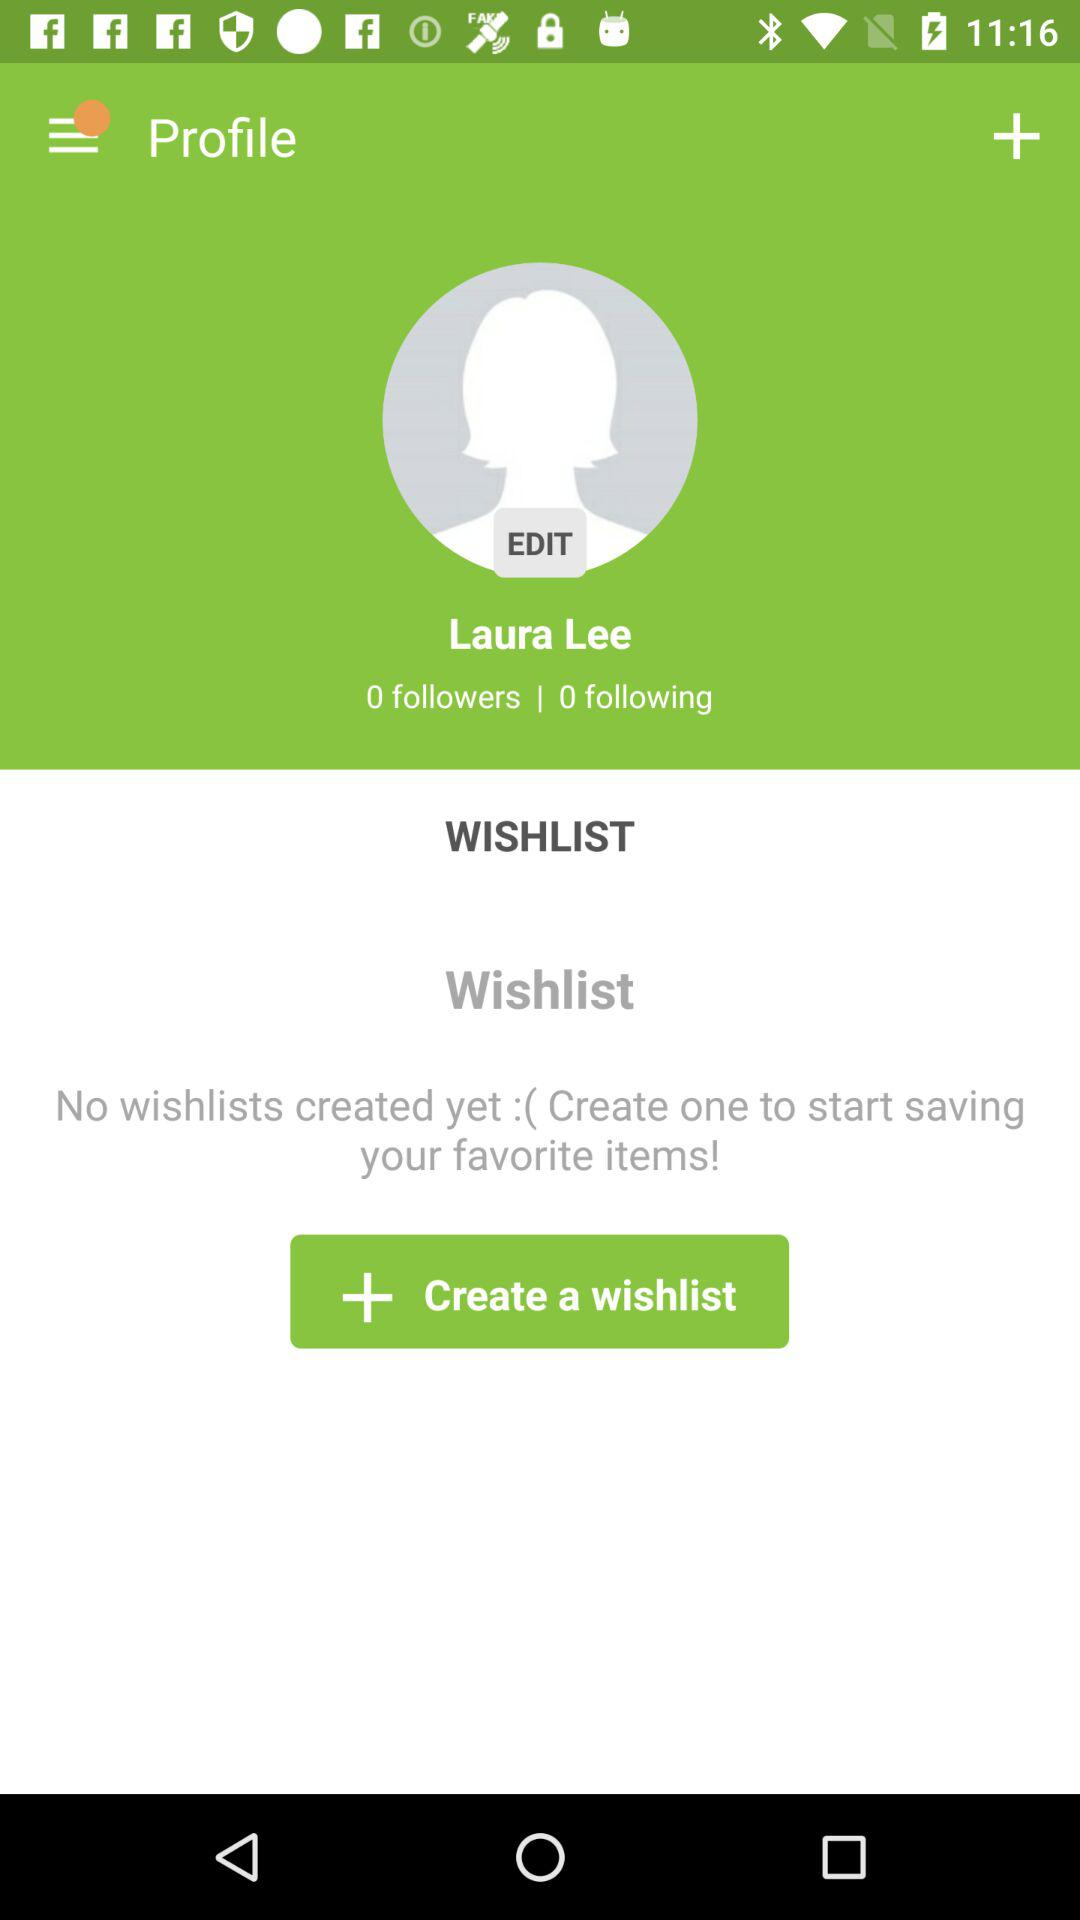How many followers does Laura Lee have?
Answer the question using a single word or phrase. 0 